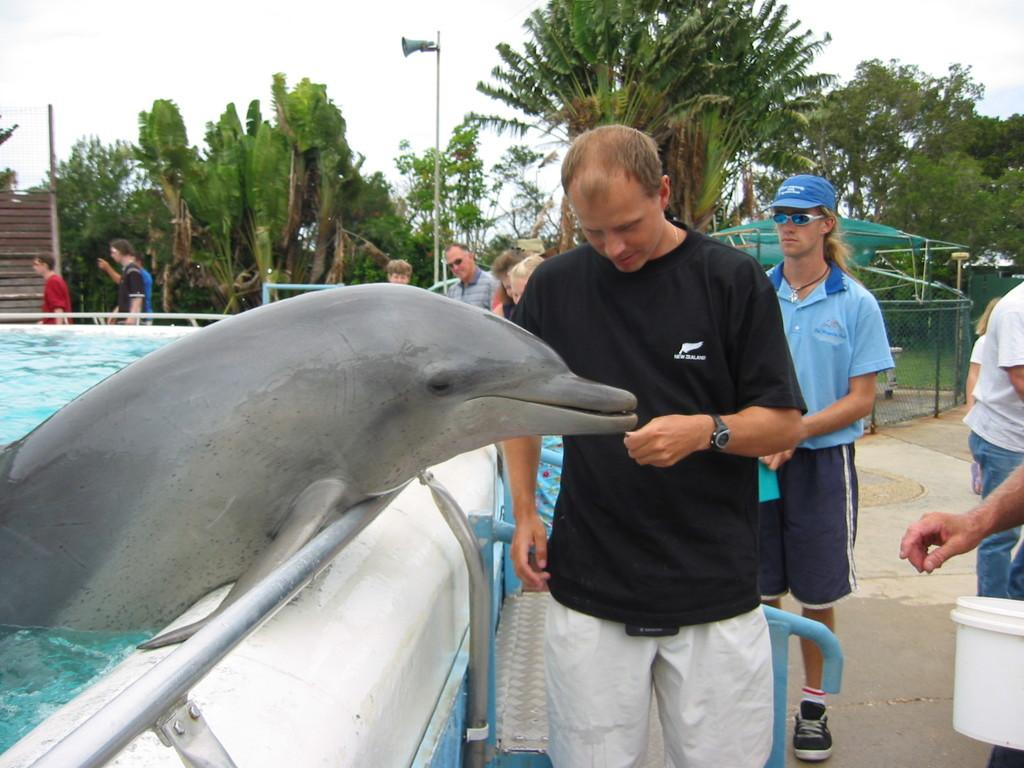What is the man in the image doing? The man is feeding a dolphin in the water. Can you describe the setting of the image? There are other persons standing in the background, people walking in the background, a tree visible in the background, the sky visible in the background, and a pole in the background. What type of brush is the man using to feed the dolphin in the image? There is no brush present in the image; the man is feeding the dolphin directly with his hand. What kind of wine is being served to the dolphin in the image? There is no wine present in the image; the man is feeding the dolphin with food, not wine. 